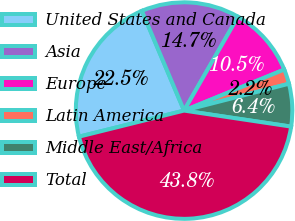Convert chart. <chart><loc_0><loc_0><loc_500><loc_500><pie_chart><fcel>United States and Canada<fcel>Asia<fcel>Europe<fcel>Latin America<fcel>Middle East/Africa<fcel>Total<nl><fcel>22.51%<fcel>14.67%<fcel>10.51%<fcel>2.2%<fcel>6.35%<fcel>43.76%<nl></chart> 